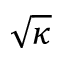<formula> <loc_0><loc_0><loc_500><loc_500>\sqrt { \kappa }</formula> 